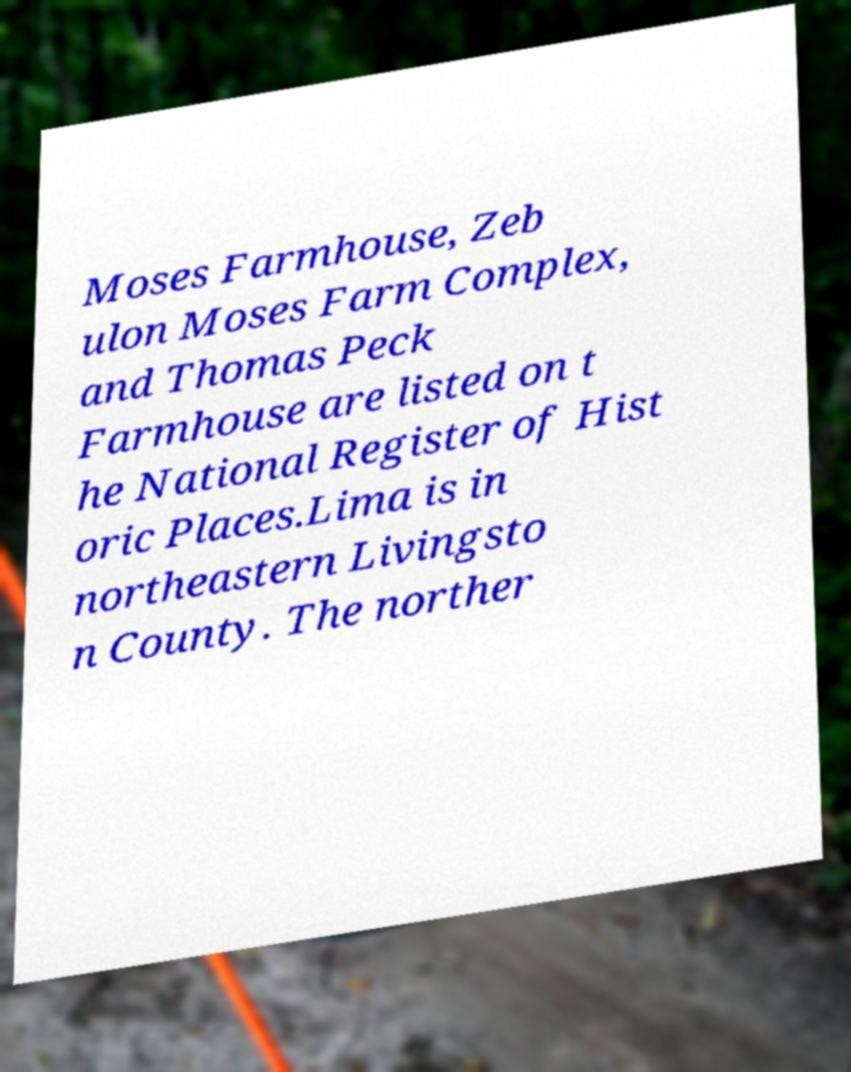Could you extract and type out the text from this image? Moses Farmhouse, Zeb ulon Moses Farm Complex, and Thomas Peck Farmhouse are listed on t he National Register of Hist oric Places.Lima is in northeastern Livingsto n County. The norther 